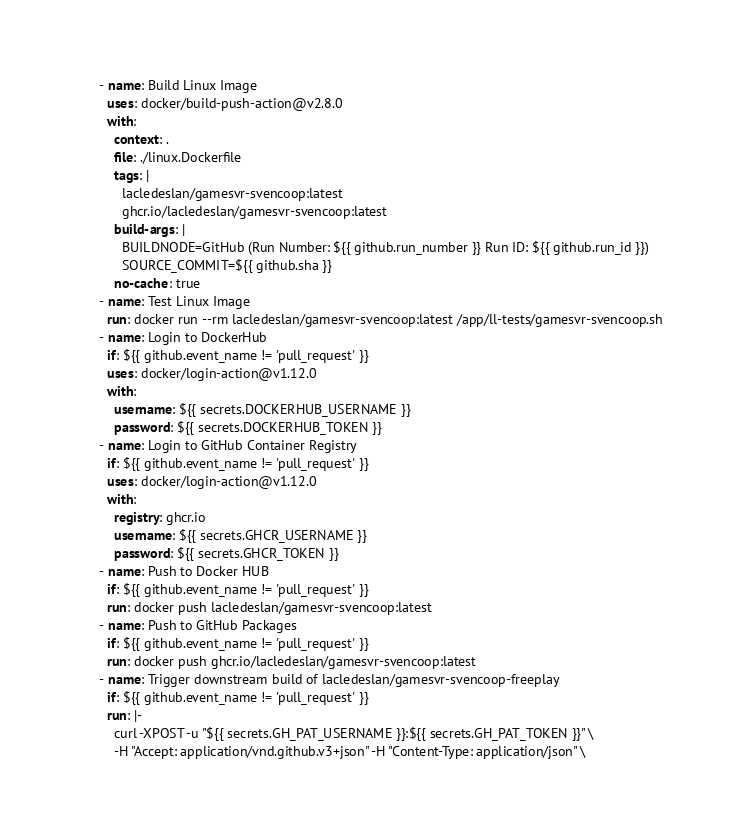<code> <loc_0><loc_0><loc_500><loc_500><_YAML_>      - name: Build Linux Image
        uses: docker/build-push-action@v2.8.0
        with:
          context: .
          file: ./linux.Dockerfile
          tags: |
            lacledeslan/gamesvr-svencoop:latest
            ghcr.io/lacledeslan/gamesvr-svencoop:latest
          build-args: |
            BUILDNODE=GitHub (Run Number: ${{ github.run_number }} Run ID: ${{ github.run_id }})
            SOURCE_COMMIT=${{ github.sha }}
          no-cache: true
      - name: Test Linux Image
        run: docker run --rm lacledeslan/gamesvr-svencoop:latest /app/ll-tests/gamesvr-svencoop.sh
      - name: Login to DockerHub
        if: ${{ github.event_name != 'pull_request' }}
        uses: docker/login-action@v1.12.0
        with:
          username: ${{ secrets.DOCKERHUB_USERNAME }}
          password: ${{ secrets.DOCKERHUB_TOKEN }}
      - name: Login to GitHub Container Registry
        if: ${{ github.event_name != 'pull_request' }}
        uses: docker/login-action@v1.12.0
        with:
          registry: ghcr.io
          username: ${{ secrets.GHCR_USERNAME }}
          password: ${{ secrets.GHCR_TOKEN }}
      - name: Push to Docker HUB
        if: ${{ github.event_name != 'pull_request' }}
        run: docker push lacledeslan/gamesvr-svencoop:latest
      - name: Push to GitHub Packages
        if: ${{ github.event_name != 'pull_request' }}
        run: docker push ghcr.io/lacledeslan/gamesvr-svencoop:latest
      - name: Trigger downstream build of lacledeslan/gamesvr-svencoop-freeplay
        if: ${{ github.event_name != 'pull_request' }}
        run: |-
          curl -XPOST -u "${{ secrets.GH_PAT_USERNAME }}:${{ secrets.GH_PAT_TOKEN }}" \
          -H "Accept: application/vnd.github.v3+json" -H "Content-Type: application/json" \</code> 